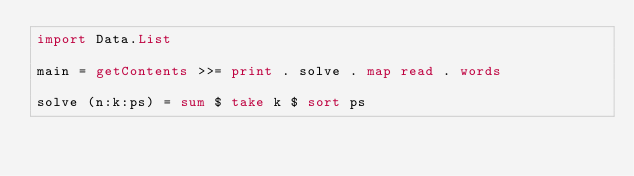Convert code to text. <code><loc_0><loc_0><loc_500><loc_500><_Haskell_>import Data.List

main = getContents >>= print . solve . map read . words

solve (n:k:ps) = sum $ take k $ sort ps</code> 